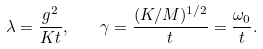Convert formula to latex. <formula><loc_0><loc_0><loc_500><loc_500>\lambda = \frac { g ^ { 2 } } { K t } , \quad \gamma = \frac { ( K / M ) ^ { 1 / 2 } } { t } = \frac { \omega _ { 0 } } { t } .</formula> 